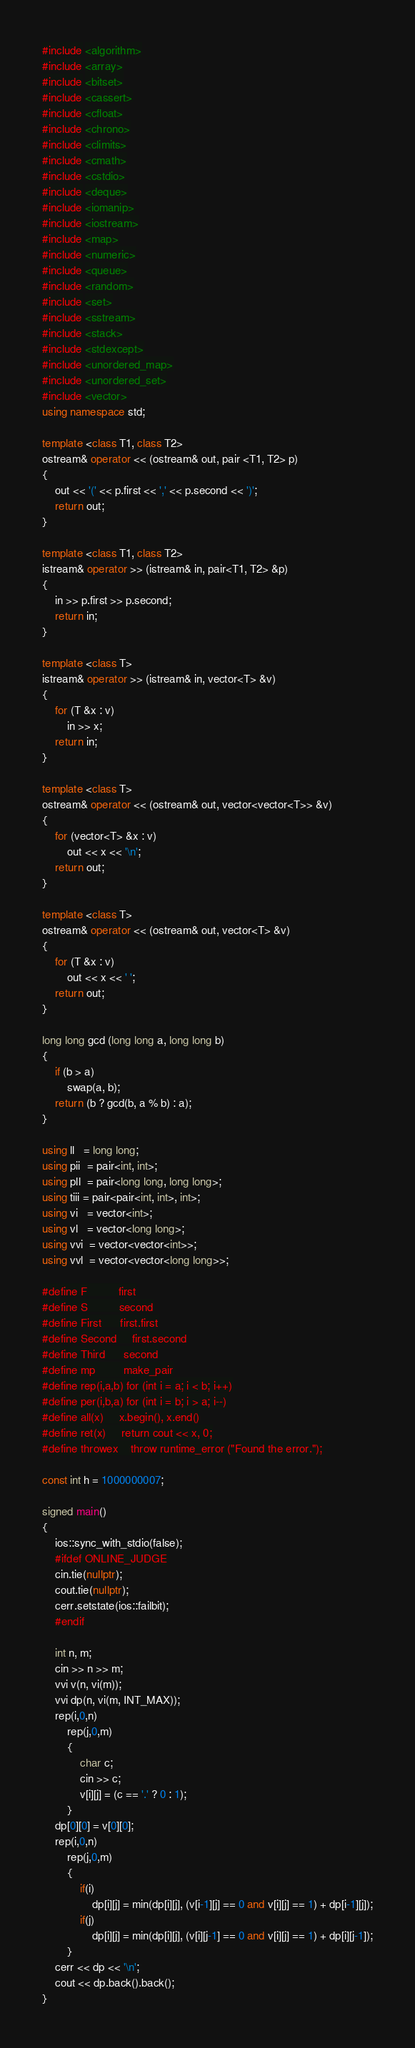<code> <loc_0><loc_0><loc_500><loc_500><_C++_>#include <algorithm>
#include <array>
#include <bitset>
#include <cassert>
#include <cfloat>
#include <chrono>
#include <climits>
#include <cmath>
#include <cstdio>
#include <deque>
#include <iomanip>
#include <iostream>
#include <map>
#include <numeric>
#include <queue>
#include <random>
#include <set>
#include <sstream>
#include <stack>
#include <stdexcept>
#include <unordered_map>
#include <unordered_set>
#include <vector>
using namespace std;

template <class T1, class T2>
ostream& operator << (ostream& out, pair <T1, T2> p)
{
	out << '(' << p.first << ',' << p.second << ')';
	return out;
}

template <class T1, class T2>
istream& operator >> (istream& in, pair<T1, T2> &p)
{
	in >> p.first >> p.second;
	return in;
}

template <class T>
istream& operator >> (istream& in, vector<T> &v)
{
	for (T &x : v)
		in >> x;
	return in;
}

template <class T>
ostream& operator << (ostream& out, vector<vector<T>> &v)
{
	for (vector<T> &x : v)
		out << x << '\n';
	return out;
}

template <class T>
ostream& operator << (ostream& out, vector<T> &v)
{
	for (T &x : v)
		out << x << ' ';
	return out;
}

long long gcd (long long a, long long b)
{
	if (b > a)
		swap(a, b);
	return (b ? gcd(b, a % b) : a);
}

using ll   = long long;
using pii  = pair<int, int>;
using pll  = pair<long long, long long>;
using tiii = pair<pair<int, int>, int>;
using vi   = vector<int>;
using vl   = vector<long long>;
using vvi  = vector<vector<int>>;
using vvl  = vector<vector<long long>>;

#define F          first
#define S          second
#define First      first.first
#define Second     first.second
#define Third      second
#define mp         make_pair
#define rep(i,a,b) for (int i = a; i < b; i++)
#define per(i,b,a) for (int i = b; i > a; i--)
#define all(x)     x.begin(), x.end()
#define ret(x)     return cout << x, 0;
#define throwex    throw runtime_error ("Found the error.");

const int h = 1000000007;

signed main()
{
	ios::sync_with_stdio(false);
	#ifdef ONLINE_JUDGE
	cin.tie(nullptr);
	cout.tie(nullptr);
	cerr.setstate(ios::failbit);
	#endif

	int n, m;
	cin >> n >> m;
	vvi v(n, vi(m));
	vvi dp(n, vi(m, INT_MAX));
	rep(i,0,n)
		rep(j,0,m)
		{
			char c;
			cin >> c;
			v[i][j] = (c == '.' ? 0 : 1);
		}
	dp[0][0] = v[0][0];
	rep(i,0,n)
		rep(j,0,m)
		{
			if(i)
				dp[i][j] = min(dp[i][j], (v[i-1][j] == 0 and v[i][j] == 1) + dp[i-1][j]);
			if(j)
				dp[i][j] = min(dp[i][j], (v[i][j-1] == 0 and v[i][j] == 1) + dp[i][j-1]);
		}
	cerr << dp << '\n';
	cout << dp.back().back();
}
</code> 